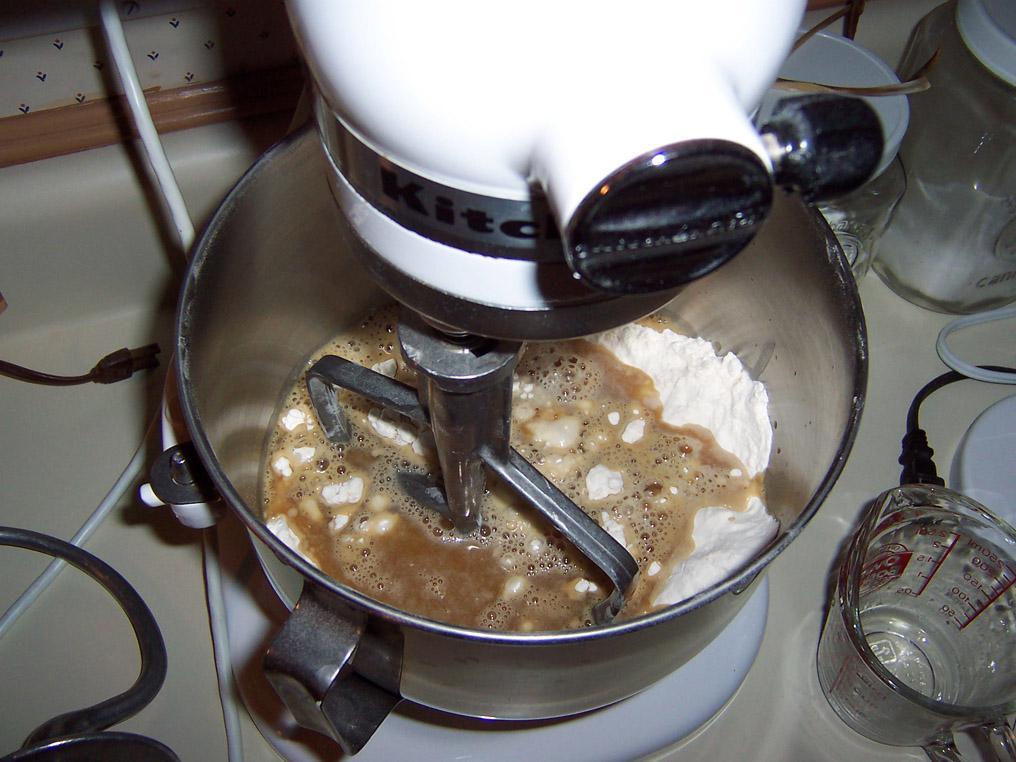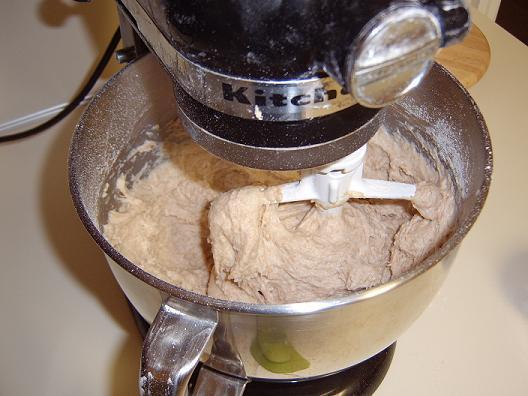The first image is the image on the left, the second image is the image on the right. Assess this claim about the two images: "Each image shows a beater in a bowl of dough, but one image features a solid disk-shaped white beater blade and the other features a bar-shaped white blade.". Correct or not? Answer yes or no. No. The first image is the image on the left, the second image is the image on the right. Given the left and right images, does the statement "IN at least one image there is a black and silver kitchenaid  kneading dough." hold true? Answer yes or no. Yes. 